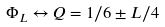Convert formula to latex. <formula><loc_0><loc_0><loc_500><loc_500>\Phi _ { L } \leftrightarrow Q = 1 / 6 \pm L / 4</formula> 